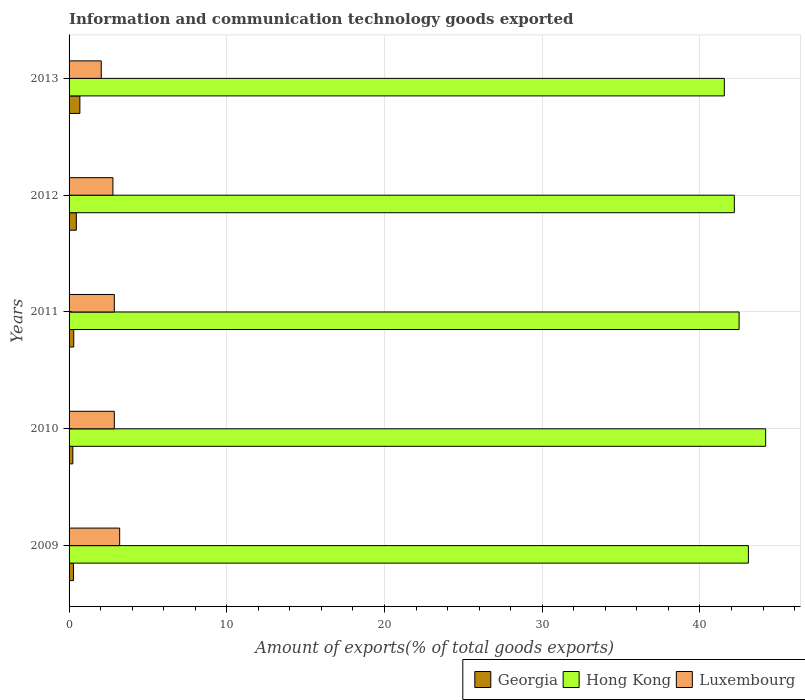How many different coloured bars are there?
Your response must be concise. 3. How many groups of bars are there?
Keep it short and to the point. 5. Are the number of bars per tick equal to the number of legend labels?
Offer a very short reply. Yes. How many bars are there on the 5th tick from the top?
Provide a short and direct response. 3. What is the amount of goods exported in Georgia in 2013?
Give a very brief answer. 0.69. Across all years, what is the maximum amount of goods exported in Hong Kong?
Provide a succinct answer. 44.16. Across all years, what is the minimum amount of goods exported in Hong Kong?
Your answer should be very brief. 41.54. What is the total amount of goods exported in Hong Kong in the graph?
Keep it short and to the point. 213.44. What is the difference between the amount of goods exported in Georgia in 2010 and that in 2011?
Keep it short and to the point. -0.06. What is the difference between the amount of goods exported in Hong Kong in 2009 and the amount of goods exported in Georgia in 2013?
Give a very brief answer. 42.38. What is the average amount of goods exported in Georgia per year?
Provide a short and direct response. 0.39. In the year 2009, what is the difference between the amount of goods exported in Luxembourg and amount of goods exported in Hong Kong?
Give a very brief answer. -39.86. What is the ratio of the amount of goods exported in Luxembourg in 2009 to that in 2012?
Make the answer very short. 1.15. What is the difference between the highest and the second highest amount of goods exported in Hong Kong?
Make the answer very short. 1.09. What is the difference between the highest and the lowest amount of goods exported in Hong Kong?
Offer a terse response. 2.62. In how many years, is the amount of goods exported in Hong Kong greater than the average amount of goods exported in Hong Kong taken over all years?
Your answer should be very brief. 2. What does the 2nd bar from the top in 2009 represents?
Your answer should be compact. Hong Kong. What does the 3rd bar from the bottom in 2012 represents?
Ensure brevity in your answer.  Luxembourg. Is it the case that in every year, the sum of the amount of goods exported in Luxembourg and amount of goods exported in Hong Kong is greater than the amount of goods exported in Georgia?
Your response must be concise. Yes. What is the difference between two consecutive major ticks on the X-axis?
Make the answer very short. 10. Are the values on the major ticks of X-axis written in scientific E-notation?
Provide a short and direct response. No. Does the graph contain any zero values?
Provide a succinct answer. No. Does the graph contain grids?
Your answer should be very brief. Yes. Where does the legend appear in the graph?
Your response must be concise. Bottom right. How many legend labels are there?
Your answer should be compact. 3. How are the legend labels stacked?
Your response must be concise. Horizontal. What is the title of the graph?
Give a very brief answer. Information and communication technology goods exported. Does "Niger" appear as one of the legend labels in the graph?
Ensure brevity in your answer.  No. What is the label or title of the X-axis?
Your response must be concise. Amount of exports(% of total goods exports). What is the label or title of the Y-axis?
Offer a terse response. Years. What is the Amount of exports(% of total goods exports) in Georgia in 2009?
Keep it short and to the point. 0.28. What is the Amount of exports(% of total goods exports) in Hong Kong in 2009?
Your answer should be very brief. 43.07. What is the Amount of exports(% of total goods exports) in Luxembourg in 2009?
Your answer should be compact. 3.21. What is the Amount of exports(% of total goods exports) in Georgia in 2010?
Your response must be concise. 0.24. What is the Amount of exports(% of total goods exports) of Hong Kong in 2010?
Provide a succinct answer. 44.16. What is the Amount of exports(% of total goods exports) of Luxembourg in 2010?
Provide a short and direct response. 2.87. What is the Amount of exports(% of total goods exports) of Georgia in 2011?
Your response must be concise. 0.3. What is the Amount of exports(% of total goods exports) of Hong Kong in 2011?
Your response must be concise. 42.48. What is the Amount of exports(% of total goods exports) in Luxembourg in 2011?
Make the answer very short. 2.87. What is the Amount of exports(% of total goods exports) in Georgia in 2012?
Your answer should be very brief. 0.46. What is the Amount of exports(% of total goods exports) in Hong Kong in 2012?
Provide a short and direct response. 42.18. What is the Amount of exports(% of total goods exports) in Luxembourg in 2012?
Offer a very short reply. 2.78. What is the Amount of exports(% of total goods exports) of Georgia in 2013?
Ensure brevity in your answer.  0.69. What is the Amount of exports(% of total goods exports) of Hong Kong in 2013?
Provide a succinct answer. 41.54. What is the Amount of exports(% of total goods exports) in Luxembourg in 2013?
Provide a succinct answer. 2.04. Across all years, what is the maximum Amount of exports(% of total goods exports) of Georgia?
Your answer should be compact. 0.69. Across all years, what is the maximum Amount of exports(% of total goods exports) of Hong Kong?
Your answer should be very brief. 44.16. Across all years, what is the maximum Amount of exports(% of total goods exports) of Luxembourg?
Your answer should be compact. 3.21. Across all years, what is the minimum Amount of exports(% of total goods exports) of Georgia?
Provide a short and direct response. 0.24. Across all years, what is the minimum Amount of exports(% of total goods exports) of Hong Kong?
Your answer should be very brief. 41.54. Across all years, what is the minimum Amount of exports(% of total goods exports) of Luxembourg?
Provide a succinct answer. 2.04. What is the total Amount of exports(% of total goods exports) of Georgia in the graph?
Provide a succinct answer. 1.96. What is the total Amount of exports(% of total goods exports) in Hong Kong in the graph?
Offer a very short reply. 213.44. What is the total Amount of exports(% of total goods exports) of Luxembourg in the graph?
Provide a succinct answer. 13.77. What is the difference between the Amount of exports(% of total goods exports) of Hong Kong in 2009 and that in 2010?
Ensure brevity in your answer.  -1.09. What is the difference between the Amount of exports(% of total goods exports) of Luxembourg in 2009 and that in 2010?
Keep it short and to the point. 0.34. What is the difference between the Amount of exports(% of total goods exports) of Georgia in 2009 and that in 2011?
Your answer should be compact. -0.02. What is the difference between the Amount of exports(% of total goods exports) of Hong Kong in 2009 and that in 2011?
Ensure brevity in your answer.  0.59. What is the difference between the Amount of exports(% of total goods exports) in Luxembourg in 2009 and that in 2011?
Your response must be concise. 0.34. What is the difference between the Amount of exports(% of total goods exports) of Georgia in 2009 and that in 2012?
Give a very brief answer. -0.18. What is the difference between the Amount of exports(% of total goods exports) in Hong Kong in 2009 and that in 2012?
Your answer should be very brief. 0.89. What is the difference between the Amount of exports(% of total goods exports) of Luxembourg in 2009 and that in 2012?
Ensure brevity in your answer.  0.43. What is the difference between the Amount of exports(% of total goods exports) in Georgia in 2009 and that in 2013?
Make the answer very short. -0.41. What is the difference between the Amount of exports(% of total goods exports) of Hong Kong in 2009 and that in 2013?
Ensure brevity in your answer.  1.53. What is the difference between the Amount of exports(% of total goods exports) in Luxembourg in 2009 and that in 2013?
Provide a short and direct response. 1.17. What is the difference between the Amount of exports(% of total goods exports) of Georgia in 2010 and that in 2011?
Keep it short and to the point. -0.06. What is the difference between the Amount of exports(% of total goods exports) of Hong Kong in 2010 and that in 2011?
Offer a very short reply. 1.68. What is the difference between the Amount of exports(% of total goods exports) in Luxembourg in 2010 and that in 2011?
Ensure brevity in your answer.  0. What is the difference between the Amount of exports(% of total goods exports) of Georgia in 2010 and that in 2012?
Make the answer very short. -0.22. What is the difference between the Amount of exports(% of total goods exports) of Hong Kong in 2010 and that in 2012?
Offer a terse response. 1.99. What is the difference between the Amount of exports(% of total goods exports) of Luxembourg in 2010 and that in 2012?
Your response must be concise. 0.09. What is the difference between the Amount of exports(% of total goods exports) of Georgia in 2010 and that in 2013?
Provide a succinct answer. -0.45. What is the difference between the Amount of exports(% of total goods exports) in Hong Kong in 2010 and that in 2013?
Keep it short and to the point. 2.62. What is the difference between the Amount of exports(% of total goods exports) in Luxembourg in 2010 and that in 2013?
Your response must be concise. 0.83. What is the difference between the Amount of exports(% of total goods exports) in Georgia in 2011 and that in 2012?
Offer a terse response. -0.16. What is the difference between the Amount of exports(% of total goods exports) in Hong Kong in 2011 and that in 2012?
Make the answer very short. 0.3. What is the difference between the Amount of exports(% of total goods exports) in Luxembourg in 2011 and that in 2012?
Provide a short and direct response. 0.09. What is the difference between the Amount of exports(% of total goods exports) of Georgia in 2011 and that in 2013?
Give a very brief answer. -0.39. What is the difference between the Amount of exports(% of total goods exports) in Hong Kong in 2011 and that in 2013?
Your answer should be very brief. 0.94. What is the difference between the Amount of exports(% of total goods exports) of Luxembourg in 2011 and that in 2013?
Ensure brevity in your answer.  0.83. What is the difference between the Amount of exports(% of total goods exports) of Georgia in 2012 and that in 2013?
Offer a terse response. -0.23. What is the difference between the Amount of exports(% of total goods exports) in Hong Kong in 2012 and that in 2013?
Your answer should be very brief. 0.63. What is the difference between the Amount of exports(% of total goods exports) in Luxembourg in 2012 and that in 2013?
Keep it short and to the point. 0.74. What is the difference between the Amount of exports(% of total goods exports) of Georgia in 2009 and the Amount of exports(% of total goods exports) of Hong Kong in 2010?
Offer a very short reply. -43.89. What is the difference between the Amount of exports(% of total goods exports) in Georgia in 2009 and the Amount of exports(% of total goods exports) in Luxembourg in 2010?
Your answer should be compact. -2.59. What is the difference between the Amount of exports(% of total goods exports) in Hong Kong in 2009 and the Amount of exports(% of total goods exports) in Luxembourg in 2010?
Your answer should be compact. 40.2. What is the difference between the Amount of exports(% of total goods exports) of Georgia in 2009 and the Amount of exports(% of total goods exports) of Hong Kong in 2011?
Provide a succinct answer. -42.2. What is the difference between the Amount of exports(% of total goods exports) of Georgia in 2009 and the Amount of exports(% of total goods exports) of Luxembourg in 2011?
Provide a short and direct response. -2.59. What is the difference between the Amount of exports(% of total goods exports) of Hong Kong in 2009 and the Amount of exports(% of total goods exports) of Luxembourg in 2011?
Give a very brief answer. 40.2. What is the difference between the Amount of exports(% of total goods exports) in Georgia in 2009 and the Amount of exports(% of total goods exports) in Hong Kong in 2012?
Your answer should be very brief. -41.9. What is the difference between the Amount of exports(% of total goods exports) of Georgia in 2009 and the Amount of exports(% of total goods exports) of Luxembourg in 2012?
Make the answer very short. -2.5. What is the difference between the Amount of exports(% of total goods exports) of Hong Kong in 2009 and the Amount of exports(% of total goods exports) of Luxembourg in 2012?
Give a very brief answer. 40.29. What is the difference between the Amount of exports(% of total goods exports) of Georgia in 2009 and the Amount of exports(% of total goods exports) of Hong Kong in 2013?
Give a very brief answer. -41.27. What is the difference between the Amount of exports(% of total goods exports) of Georgia in 2009 and the Amount of exports(% of total goods exports) of Luxembourg in 2013?
Offer a very short reply. -1.76. What is the difference between the Amount of exports(% of total goods exports) in Hong Kong in 2009 and the Amount of exports(% of total goods exports) in Luxembourg in 2013?
Provide a short and direct response. 41.03. What is the difference between the Amount of exports(% of total goods exports) of Georgia in 2010 and the Amount of exports(% of total goods exports) of Hong Kong in 2011?
Offer a very short reply. -42.24. What is the difference between the Amount of exports(% of total goods exports) in Georgia in 2010 and the Amount of exports(% of total goods exports) in Luxembourg in 2011?
Ensure brevity in your answer.  -2.63. What is the difference between the Amount of exports(% of total goods exports) in Hong Kong in 2010 and the Amount of exports(% of total goods exports) in Luxembourg in 2011?
Provide a succinct answer. 41.3. What is the difference between the Amount of exports(% of total goods exports) in Georgia in 2010 and the Amount of exports(% of total goods exports) in Hong Kong in 2012?
Offer a very short reply. -41.94. What is the difference between the Amount of exports(% of total goods exports) in Georgia in 2010 and the Amount of exports(% of total goods exports) in Luxembourg in 2012?
Ensure brevity in your answer.  -2.54. What is the difference between the Amount of exports(% of total goods exports) of Hong Kong in 2010 and the Amount of exports(% of total goods exports) of Luxembourg in 2012?
Make the answer very short. 41.38. What is the difference between the Amount of exports(% of total goods exports) of Georgia in 2010 and the Amount of exports(% of total goods exports) of Hong Kong in 2013?
Offer a terse response. -41.31. What is the difference between the Amount of exports(% of total goods exports) in Georgia in 2010 and the Amount of exports(% of total goods exports) in Luxembourg in 2013?
Offer a very short reply. -1.8. What is the difference between the Amount of exports(% of total goods exports) of Hong Kong in 2010 and the Amount of exports(% of total goods exports) of Luxembourg in 2013?
Your response must be concise. 42.12. What is the difference between the Amount of exports(% of total goods exports) of Georgia in 2011 and the Amount of exports(% of total goods exports) of Hong Kong in 2012?
Keep it short and to the point. -41.88. What is the difference between the Amount of exports(% of total goods exports) in Georgia in 2011 and the Amount of exports(% of total goods exports) in Luxembourg in 2012?
Offer a very short reply. -2.48. What is the difference between the Amount of exports(% of total goods exports) of Hong Kong in 2011 and the Amount of exports(% of total goods exports) of Luxembourg in 2012?
Your response must be concise. 39.7. What is the difference between the Amount of exports(% of total goods exports) of Georgia in 2011 and the Amount of exports(% of total goods exports) of Hong Kong in 2013?
Offer a very short reply. -41.25. What is the difference between the Amount of exports(% of total goods exports) in Georgia in 2011 and the Amount of exports(% of total goods exports) in Luxembourg in 2013?
Offer a very short reply. -1.74. What is the difference between the Amount of exports(% of total goods exports) in Hong Kong in 2011 and the Amount of exports(% of total goods exports) in Luxembourg in 2013?
Make the answer very short. 40.44. What is the difference between the Amount of exports(% of total goods exports) of Georgia in 2012 and the Amount of exports(% of total goods exports) of Hong Kong in 2013?
Provide a short and direct response. -41.08. What is the difference between the Amount of exports(% of total goods exports) in Georgia in 2012 and the Amount of exports(% of total goods exports) in Luxembourg in 2013?
Offer a terse response. -1.58. What is the difference between the Amount of exports(% of total goods exports) of Hong Kong in 2012 and the Amount of exports(% of total goods exports) of Luxembourg in 2013?
Offer a terse response. 40.14. What is the average Amount of exports(% of total goods exports) in Georgia per year?
Provide a short and direct response. 0.39. What is the average Amount of exports(% of total goods exports) of Hong Kong per year?
Your response must be concise. 42.69. What is the average Amount of exports(% of total goods exports) in Luxembourg per year?
Ensure brevity in your answer.  2.75. In the year 2009, what is the difference between the Amount of exports(% of total goods exports) of Georgia and Amount of exports(% of total goods exports) of Hong Kong?
Your answer should be compact. -42.79. In the year 2009, what is the difference between the Amount of exports(% of total goods exports) of Georgia and Amount of exports(% of total goods exports) of Luxembourg?
Your answer should be very brief. -2.93. In the year 2009, what is the difference between the Amount of exports(% of total goods exports) in Hong Kong and Amount of exports(% of total goods exports) in Luxembourg?
Provide a short and direct response. 39.86. In the year 2010, what is the difference between the Amount of exports(% of total goods exports) of Georgia and Amount of exports(% of total goods exports) of Hong Kong?
Provide a short and direct response. -43.93. In the year 2010, what is the difference between the Amount of exports(% of total goods exports) of Georgia and Amount of exports(% of total goods exports) of Luxembourg?
Make the answer very short. -2.63. In the year 2010, what is the difference between the Amount of exports(% of total goods exports) in Hong Kong and Amount of exports(% of total goods exports) in Luxembourg?
Provide a short and direct response. 41.3. In the year 2011, what is the difference between the Amount of exports(% of total goods exports) in Georgia and Amount of exports(% of total goods exports) in Hong Kong?
Your answer should be very brief. -42.18. In the year 2011, what is the difference between the Amount of exports(% of total goods exports) of Georgia and Amount of exports(% of total goods exports) of Luxembourg?
Your answer should be compact. -2.57. In the year 2011, what is the difference between the Amount of exports(% of total goods exports) of Hong Kong and Amount of exports(% of total goods exports) of Luxembourg?
Ensure brevity in your answer.  39.61. In the year 2012, what is the difference between the Amount of exports(% of total goods exports) of Georgia and Amount of exports(% of total goods exports) of Hong Kong?
Give a very brief answer. -41.72. In the year 2012, what is the difference between the Amount of exports(% of total goods exports) of Georgia and Amount of exports(% of total goods exports) of Luxembourg?
Give a very brief answer. -2.32. In the year 2012, what is the difference between the Amount of exports(% of total goods exports) of Hong Kong and Amount of exports(% of total goods exports) of Luxembourg?
Your answer should be compact. 39.4. In the year 2013, what is the difference between the Amount of exports(% of total goods exports) in Georgia and Amount of exports(% of total goods exports) in Hong Kong?
Offer a terse response. -40.86. In the year 2013, what is the difference between the Amount of exports(% of total goods exports) of Georgia and Amount of exports(% of total goods exports) of Luxembourg?
Your response must be concise. -1.35. In the year 2013, what is the difference between the Amount of exports(% of total goods exports) of Hong Kong and Amount of exports(% of total goods exports) of Luxembourg?
Keep it short and to the point. 39.5. What is the ratio of the Amount of exports(% of total goods exports) in Georgia in 2009 to that in 2010?
Ensure brevity in your answer.  1.17. What is the ratio of the Amount of exports(% of total goods exports) of Hong Kong in 2009 to that in 2010?
Keep it short and to the point. 0.98. What is the ratio of the Amount of exports(% of total goods exports) in Luxembourg in 2009 to that in 2010?
Offer a very short reply. 1.12. What is the ratio of the Amount of exports(% of total goods exports) in Hong Kong in 2009 to that in 2011?
Your answer should be compact. 1.01. What is the ratio of the Amount of exports(% of total goods exports) in Luxembourg in 2009 to that in 2011?
Offer a terse response. 1.12. What is the ratio of the Amount of exports(% of total goods exports) of Georgia in 2009 to that in 2012?
Your response must be concise. 0.61. What is the ratio of the Amount of exports(% of total goods exports) of Hong Kong in 2009 to that in 2012?
Your answer should be compact. 1.02. What is the ratio of the Amount of exports(% of total goods exports) of Luxembourg in 2009 to that in 2012?
Your answer should be compact. 1.15. What is the ratio of the Amount of exports(% of total goods exports) of Georgia in 2009 to that in 2013?
Your response must be concise. 0.41. What is the ratio of the Amount of exports(% of total goods exports) in Hong Kong in 2009 to that in 2013?
Offer a very short reply. 1.04. What is the ratio of the Amount of exports(% of total goods exports) of Luxembourg in 2009 to that in 2013?
Offer a terse response. 1.57. What is the ratio of the Amount of exports(% of total goods exports) in Georgia in 2010 to that in 2011?
Ensure brevity in your answer.  0.81. What is the ratio of the Amount of exports(% of total goods exports) in Hong Kong in 2010 to that in 2011?
Your response must be concise. 1.04. What is the ratio of the Amount of exports(% of total goods exports) of Georgia in 2010 to that in 2012?
Your answer should be compact. 0.52. What is the ratio of the Amount of exports(% of total goods exports) of Hong Kong in 2010 to that in 2012?
Ensure brevity in your answer.  1.05. What is the ratio of the Amount of exports(% of total goods exports) of Luxembourg in 2010 to that in 2012?
Keep it short and to the point. 1.03. What is the ratio of the Amount of exports(% of total goods exports) in Georgia in 2010 to that in 2013?
Offer a terse response. 0.35. What is the ratio of the Amount of exports(% of total goods exports) in Hong Kong in 2010 to that in 2013?
Ensure brevity in your answer.  1.06. What is the ratio of the Amount of exports(% of total goods exports) of Luxembourg in 2010 to that in 2013?
Provide a short and direct response. 1.41. What is the ratio of the Amount of exports(% of total goods exports) in Georgia in 2011 to that in 2012?
Offer a terse response. 0.64. What is the ratio of the Amount of exports(% of total goods exports) of Hong Kong in 2011 to that in 2012?
Provide a succinct answer. 1.01. What is the ratio of the Amount of exports(% of total goods exports) of Luxembourg in 2011 to that in 2012?
Keep it short and to the point. 1.03. What is the ratio of the Amount of exports(% of total goods exports) in Georgia in 2011 to that in 2013?
Make the answer very short. 0.43. What is the ratio of the Amount of exports(% of total goods exports) in Hong Kong in 2011 to that in 2013?
Ensure brevity in your answer.  1.02. What is the ratio of the Amount of exports(% of total goods exports) of Luxembourg in 2011 to that in 2013?
Make the answer very short. 1.41. What is the ratio of the Amount of exports(% of total goods exports) in Georgia in 2012 to that in 2013?
Your response must be concise. 0.67. What is the ratio of the Amount of exports(% of total goods exports) in Hong Kong in 2012 to that in 2013?
Provide a short and direct response. 1.02. What is the ratio of the Amount of exports(% of total goods exports) of Luxembourg in 2012 to that in 2013?
Offer a terse response. 1.36. What is the difference between the highest and the second highest Amount of exports(% of total goods exports) of Georgia?
Your answer should be compact. 0.23. What is the difference between the highest and the second highest Amount of exports(% of total goods exports) in Hong Kong?
Your answer should be compact. 1.09. What is the difference between the highest and the second highest Amount of exports(% of total goods exports) in Luxembourg?
Provide a succinct answer. 0.34. What is the difference between the highest and the lowest Amount of exports(% of total goods exports) in Georgia?
Provide a succinct answer. 0.45. What is the difference between the highest and the lowest Amount of exports(% of total goods exports) of Hong Kong?
Provide a succinct answer. 2.62. What is the difference between the highest and the lowest Amount of exports(% of total goods exports) in Luxembourg?
Your answer should be very brief. 1.17. 